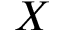Convert formula to latex. <formula><loc_0><loc_0><loc_500><loc_500>X</formula> 